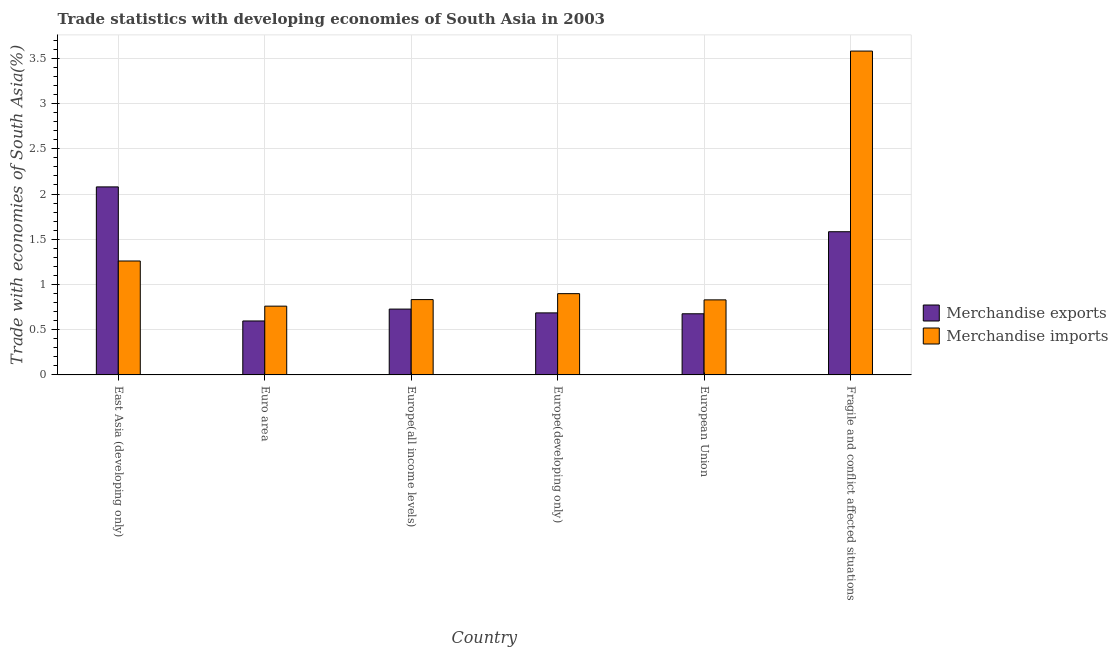How many different coloured bars are there?
Provide a succinct answer. 2. How many groups of bars are there?
Your answer should be very brief. 6. Are the number of bars per tick equal to the number of legend labels?
Provide a succinct answer. Yes. How many bars are there on the 3rd tick from the right?
Your answer should be compact. 2. What is the label of the 4th group of bars from the left?
Offer a very short reply. Europe(developing only). In how many cases, is the number of bars for a given country not equal to the number of legend labels?
Your answer should be very brief. 0. What is the merchandise imports in Europe(all income levels)?
Your answer should be compact. 0.83. Across all countries, what is the maximum merchandise exports?
Your answer should be compact. 2.08. Across all countries, what is the minimum merchandise exports?
Your answer should be very brief. 0.6. In which country was the merchandise imports maximum?
Your answer should be very brief. Fragile and conflict affected situations. In which country was the merchandise imports minimum?
Ensure brevity in your answer.  Euro area. What is the total merchandise exports in the graph?
Your response must be concise. 6.35. What is the difference between the merchandise exports in Europe(all income levels) and that in European Union?
Make the answer very short. 0.05. What is the difference between the merchandise imports in Euro area and the merchandise exports in European Union?
Offer a very short reply. 0.08. What is the average merchandise exports per country?
Your answer should be compact. 1.06. What is the difference between the merchandise exports and merchandise imports in East Asia (developing only)?
Ensure brevity in your answer.  0.82. In how many countries, is the merchandise exports greater than 3.5 %?
Offer a terse response. 0. What is the ratio of the merchandise imports in Europe(all income levels) to that in Fragile and conflict affected situations?
Your answer should be compact. 0.23. Is the merchandise exports in Euro area less than that in European Union?
Offer a very short reply. Yes. What is the difference between the highest and the second highest merchandise imports?
Your response must be concise. 2.32. What is the difference between the highest and the lowest merchandise imports?
Ensure brevity in your answer.  2.82. How many countries are there in the graph?
Keep it short and to the point. 6. Where does the legend appear in the graph?
Your response must be concise. Center right. What is the title of the graph?
Make the answer very short. Trade statistics with developing economies of South Asia in 2003. What is the label or title of the X-axis?
Give a very brief answer. Country. What is the label or title of the Y-axis?
Offer a terse response. Trade with economies of South Asia(%). What is the Trade with economies of South Asia(%) of Merchandise exports in East Asia (developing only)?
Keep it short and to the point. 2.08. What is the Trade with economies of South Asia(%) of Merchandise imports in East Asia (developing only)?
Keep it short and to the point. 1.26. What is the Trade with economies of South Asia(%) of Merchandise exports in Euro area?
Give a very brief answer. 0.6. What is the Trade with economies of South Asia(%) of Merchandise imports in Euro area?
Offer a terse response. 0.76. What is the Trade with economies of South Asia(%) in Merchandise exports in Europe(all income levels)?
Give a very brief answer. 0.73. What is the Trade with economies of South Asia(%) of Merchandise imports in Europe(all income levels)?
Keep it short and to the point. 0.83. What is the Trade with economies of South Asia(%) in Merchandise exports in Europe(developing only)?
Provide a succinct answer. 0.69. What is the Trade with economies of South Asia(%) in Merchandise imports in Europe(developing only)?
Your answer should be compact. 0.9. What is the Trade with economies of South Asia(%) of Merchandise exports in European Union?
Your answer should be compact. 0.68. What is the Trade with economies of South Asia(%) in Merchandise imports in European Union?
Offer a very short reply. 0.83. What is the Trade with economies of South Asia(%) of Merchandise exports in Fragile and conflict affected situations?
Offer a very short reply. 1.58. What is the Trade with economies of South Asia(%) of Merchandise imports in Fragile and conflict affected situations?
Keep it short and to the point. 3.58. Across all countries, what is the maximum Trade with economies of South Asia(%) of Merchandise exports?
Provide a succinct answer. 2.08. Across all countries, what is the maximum Trade with economies of South Asia(%) in Merchandise imports?
Your answer should be very brief. 3.58. Across all countries, what is the minimum Trade with economies of South Asia(%) of Merchandise exports?
Keep it short and to the point. 0.6. Across all countries, what is the minimum Trade with economies of South Asia(%) in Merchandise imports?
Ensure brevity in your answer.  0.76. What is the total Trade with economies of South Asia(%) in Merchandise exports in the graph?
Provide a short and direct response. 6.35. What is the total Trade with economies of South Asia(%) in Merchandise imports in the graph?
Provide a short and direct response. 8.16. What is the difference between the Trade with economies of South Asia(%) of Merchandise exports in East Asia (developing only) and that in Euro area?
Ensure brevity in your answer.  1.48. What is the difference between the Trade with economies of South Asia(%) of Merchandise imports in East Asia (developing only) and that in Euro area?
Your response must be concise. 0.5. What is the difference between the Trade with economies of South Asia(%) in Merchandise exports in East Asia (developing only) and that in Europe(all income levels)?
Offer a very short reply. 1.35. What is the difference between the Trade with economies of South Asia(%) in Merchandise imports in East Asia (developing only) and that in Europe(all income levels)?
Your answer should be compact. 0.43. What is the difference between the Trade with economies of South Asia(%) in Merchandise exports in East Asia (developing only) and that in Europe(developing only)?
Make the answer very short. 1.39. What is the difference between the Trade with economies of South Asia(%) in Merchandise imports in East Asia (developing only) and that in Europe(developing only)?
Provide a succinct answer. 0.36. What is the difference between the Trade with economies of South Asia(%) in Merchandise exports in East Asia (developing only) and that in European Union?
Your answer should be compact. 1.4. What is the difference between the Trade with economies of South Asia(%) of Merchandise imports in East Asia (developing only) and that in European Union?
Give a very brief answer. 0.43. What is the difference between the Trade with economies of South Asia(%) of Merchandise exports in East Asia (developing only) and that in Fragile and conflict affected situations?
Offer a very short reply. 0.5. What is the difference between the Trade with economies of South Asia(%) in Merchandise imports in East Asia (developing only) and that in Fragile and conflict affected situations?
Keep it short and to the point. -2.32. What is the difference between the Trade with economies of South Asia(%) of Merchandise exports in Euro area and that in Europe(all income levels)?
Offer a terse response. -0.13. What is the difference between the Trade with economies of South Asia(%) in Merchandise imports in Euro area and that in Europe(all income levels)?
Offer a terse response. -0.07. What is the difference between the Trade with economies of South Asia(%) in Merchandise exports in Euro area and that in Europe(developing only)?
Your answer should be very brief. -0.09. What is the difference between the Trade with economies of South Asia(%) of Merchandise imports in Euro area and that in Europe(developing only)?
Give a very brief answer. -0.14. What is the difference between the Trade with economies of South Asia(%) in Merchandise exports in Euro area and that in European Union?
Your answer should be very brief. -0.08. What is the difference between the Trade with economies of South Asia(%) in Merchandise imports in Euro area and that in European Union?
Your response must be concise. -0.07. What is the difference between the Trade with economies of South Asia(%) in Merchandise exports in Euro area and that in Fragile and conflict affected situations?
Give a very brief answer. -0.99. What is the difference between the Trade with economies of South Asia(%) of Merchandise imports in Euro area and that in Fragile and conflict affected situations?
Give a very brief answer. -2.82. What is the difference between the Trade with economies of South Asia(%) in Merchandise exports in Europe(all income levels) and that in Europe(developing only)?
Make the answer very short. 0.04. What is the difference between the Trade with economies of South Asia(%) of Merchandise imports in Europe(all income levels) and that in Europe(developing only)?
Your answer should be compact. -0.07. What is the difference between the Trade with economies of South Asia(%) in Merchandise exports in Europe(all income levels) and that in European Union?
Your response must be concise. 0.05. What is the difference between the Trade with economies of South Asia(%) of Merchandise imports in Europe(all income levels) and that in European Union?
Provide a short and direct response. 0. What is the difference between the Trade with economies of South Asia(%) in Merchandise exports in Europe(all income levels) and that in Fragile and conflict affected situations?
Your answer should be compact. -0.86. What is the difference between the Trade with economies of South Asia(%) in Merchandise imports in Europe(all income levels) and that in Fragile and conflict affected situations?
Provide a succinct answer. -2.75. What is the difference between the Trade with economies of South Asia(%) of Merchandise exports in Europe(developing only) and that in European Union?
Provide a short and direct response. 0.01. What is the difference between the Trade with economies of South Asia(%) in Merchandise imports in Europe(developing only) and that in European Union?
Provide a succinct answer. 0.07. What is the difference between the Trade with economies of South Asia(%) in Merchandise exports in Europe(developing only) and that in Fragile and conflict affected situations?
Keep it short and to the point. -0.9. What is the difference between the Trade with economies of South Asia(%) of Merchandise imports in Europe(developing only) and that in Fragile and conflict affected situations?
Ensure brevity in your answer.  -2.68. What is the difference between the Trade with economies of South Asia(%) in Merchandise exports in European Union and that in Fragile and conflict affected situations?
Make the answer very short. -0.91. What is the difference between the Trade with economies of South Asia(%) of Merchandise imports in European Union and that in Fragile and conflict affected situations?
Offer a terse response. -2.75. What is the difference between the Trade with economies of South Asia(%) in Merchandise exports in East Asia (developing only) and the Trade with economies of South Asia(%) in Merchandise imports in Euro area?
Ensure brevity in your answer.  1.32. What is the difference between the Trade with economies of South Asia(%) in Merchandise exports in East Asia (developing only) and the Trade with economies of South Asia(%) in Merchandise imports in Europe(all income levels)?
Your response must be concise. 1.25. What is the difference between the Trade with economies of South Asia(%) in Merchandise exports in East Asia (developing only) and the Trade with economies of South Asia(%) in Merchandise imports in Europe(developing only)?
Offer a very short reply. 1.18. What is the difference between the Trade with economies of South Asia(%) of Merchandise exports in East Asia (developing only) and the Trade with economies of South Asia(%) of Merchandise imports in European Union?
Offer a very short reply. 1.25. What is the difference between the Trade with economies of South Asia(%) in Merchandise exports in East Asia (developing only) and the Trade with economies of South Asia(%) in Merchandise imports in Fragile and conflict affected situations?
Keep it short and to the point. -1.5. What is the difference between the Trade with economies of South Asia(%) of Merchandise exports in Euro area and the Trade with economies of South Asia(%) of Merchandise imports in Europe(all income levels)?
Provide a short and direct response. -0.24. What is the difference between the Trade with economies of South Asia(%) of Merchandise exports in Euro area and the Trade with economies of South Asia(%) of Merchandise imports in Europe(developing only)?
Your answer should be compact. -0.3. What is the difference between the Trade with economies of South Asia(%) in Merchandise exports in Euro area and the Trade with economies of South Asia(%) in Merchandise imports in European Union?
Provide a succinct answer. -0.23. What is the difference between the Trade with economies of South Asia(%) in Merchandise exports in Euro area and the Trade with economies of South Asia(%) in Merchandise imports in Fragile and conflict affected situations?
Your answer should be compact. -2.98. What is the difference between the Trade with economies of South Asia(%) of Merchandise exports in Europe(all income levels) and the Trade with economies of South Asia(%) of Merchandise imports in Europe(developing only)?
Offer a very short reply. -0.17. What is the difference between the Trade with economies of South Asia(%) of Merchandise exports in Europe(all income levels) and the Trade with economies of South Asia(%) of Merchandise imports in European Union?
Your answer should be very brief. -0.1. What is the difference between the Trade with economies of South Asia(%) in Merchandise exports in Europe(all income levels) and the Trade with economies of South Asia(%) in Merchandise imports in Fragile and conflict affected situations?
Your response must be concise. -2.85. What is the difference between the Trade with economies of South Asia(%) of Merchandise exports in Europe(developing only) and the Trade with economies of South Asia(%) of Merchandise imports in European Union?
Your answer should be very brief. -0.14. What is the difference between the Trade with economies of South Asia(%) in Merchandise exports in Europe(developing only) and the Trade with economies of South Asia(%) in Merchandise imports in Fragile and conflict affected situations?
Ensure brevity in your answer.  -2.89. What is the difference between the Trade with economies of South Asia(%) in Merchandise exports in European Union and the Trade with economies of South Asia(%) in Merchandise imports in Fragile and conflict affected situations?
Your response must be concise. -2.9. What is the average Trade with economies of South Asia(%) in Merchandise exports per country?
Your answer should be compact. 1.06. What is the average Trade with economies of South Asia(%) in Merchandise imports per country?
Provide a short and direct response. 1.36. What is the difference between the Trade with economies of South Asia(%) of Merchandise exports and Trade with economies of South Asia(%) of Merchandise imports in East Asia (developing only)?
Provide a short and direct response. 0.82. What is the difference between the Trade with economies of South Asia(%) in Merchandise exports and Trade with economies of South Asia(%) in Merchandise imports in Euro area?
Provide a succinct answer. -0.16. What is the difference between the Trade with economies of South Asia(%) of Merchandise exports and Trade with economies of South Asia(%) of Merchandise imports in Europe(all income levels)?
Offer a very short reply. -0.1. What is the difference between the Trade with economies of South Asia(%) in Merchandise exports and Trade with economies of South Asia(%) in Merchandise imports in Europe(developing only)?
Keep it short and to the point. -0.21. What is the difference between the Trade with economies of South Asia(%) of Merchandise exports and Trade with economies of South Asia(%) of Merchandise imports in European Union?
Give a very brief answer. -0.15. What is the difference between the Trade with economies of South Asia(%) in Merchandise exports and Trade with economies of South Asia(%) in Merchandise imports in Fragile and conflict affected situations?
Provide a short and direct response. -2. What is the ratio of the Trade with economies of South Asia(%) of Merchandise exports in East Asia (developing only) to that in Euro area?
Your response must be concise. 3.49. What is the ratio of the Trade with economies of South Asia(%) in Merchandise imports in East Asia (developing only) to that in Euro area?
Provide a short and direct response. 1.66. What is the ratio of the Trade with economies of South Asia(%) of Merchandise exports in East Asia (developing only) to that in Europe(all income levels)?
Your answer should be very brief. 2.86. What is the ratio of the Trade with economies of South Asia(%) in Merchandise imports in East Asia (developing only) to that in Europe(all income levels)?
Ensure brevity in your answer.  1.51. What is the ratio of the Trade with economies of South Asia(%) in Merchandise exports in East Asia (developing only) to that in Europe(developing only)?
Your answer should be compact. 3.03. What is the ratio of the Trade with economies of South Asia(%) in Merchandise imports in East Asia (developing only) to that in Europe(developing only)?
Keep it short and to the point. 1.4. What is the ratio of the Trade with economies of South Asia(%) in Merchandise exports in East Asia (developing only) to that in European Union?
Your answer should be compact. 3.08. What is the ratio of the Trade with economies of South Asia(%) in Merchandise imports in East Asia (developing only) to that in European Union?
Your answer should be compact. 1.52. What is the ratio of the Trade with economies of South Asia(%) of Merchandise exports in East Asia (developing only) to that in Fragile and conflict affected situations?
Provide a succinct answer. 1.31. What is the ratio of the Trade with economies of South Asia(%) of Merchandise imports in East Asia (developing only) to that in Fragile and conflict affected situations?
Your answer should be very brief. 0.35. What is the ratio of the Trade with economies of South Asia(%) of Merchandise exports in Euro area to that in Europe(all income levels)?
Offer a very short reply. 0.82. What is the ratio of the Trade with economies of South Asia(%) in Merchandise imports in Euro area to that in Europe(all income levels)?
Ensure brevity in your answer.  0.91. What is the ratio of the Trade with economies of South Asia(%) in Merchandise exports in Euro area to that in Europe(developing only)?
Your response must be concise. 0.87. What is the ratio of the Trade with economies of South Asia(%) in Merchandise imports in Euro area to that in Europe(developing only)?
Your answer should be very brief. 0.85. What is the ratio of the Trade with economies of South Asia(%) of Merchandise exports in Euro area to that in European Union?
Offer a terse response. 0.88. What is the ratio of the Trade with economies of South Asia(%) in Merchandise imports in Euro area to that in European Union?
Keep it short and to the point. 0.92. What is the ratio of the Trade with economies of South Asia(%) of Merchandise exports in Euro area to that in Fragile and conflict affected situations?
Make the answer very short. 0.38. What is the ratio of the Trade with economies of South Asia(%) of Merchandise imports in Euro area to that in Fragile and conflict affected situations?
Keep it short and to the point. 0.21. What is the ratio of the Trade with economies of South Asia(%) of Merchandise exports in Europe(all income levels) to that in Europe(developing only)?
Offer a terse response. 1.06. What is the ratio of the Trade with economies of South Asia(%) of Merchandise imports in Europe(all income levels) to that in Europe(developing only)?
Give a very brief answer. 0.93. What is the ratio of the Trade with economies of South Asia(%) of Merchandise exports in Europe(all income levels) to that in European Union?
Offer a very short reply. 1.08. What is the ratio of the Trade with economies of South Asia(%) in Merchandise exports in Europe(all income levels) to that in Fragile and conflict affected situations?
Ensure brevity in your answer.  0.46. What is the ratio of the Trade with economies of South Asia(%) in Merchandise imports in Europe(all income levels) to that in Fragile and conflict affected situations?
Give a very brief answer. 0.23. What is the ratio of the Trade with economies of South Asia(%) of Merchandise exports in Europe(developing only) to that in European Union?
Give a very brief answer. 1.01. What is the ratio of the Trade with economies of South Asia(%) in Merchandise imports in Europe(developing only) to that in European Union?
Your answer should be very brief. 1.08. What is the ratio of the Trade with economies of South Asia(%) of Merchandise exports in Europe(developing only) to that in Fragile and conflict affected situations?
Offer a very short reply. 0.43. What is the ratio of the Trade with economies of South Asia(%) in Merchandise imports in Europe(developing only) to that in Fragile and conflict affected situations?
Provide a short and direct response. 0.25. What is the ratio of the Trade with economies of South Asia(%) of Merchandise exports in European Union to that in Fragile and conflict affected situations?
Give a very brief answer. 0.43. What is the ratio of the Trade with economies of South Asia(%) in Merchandise imports in European Union to that in Fragile and conflict affected situations?
Keep it short and to the point. 0.23. What is the difference between the highest and the second highest Trade with economies of South Asia(%) in Merchandise exports?
Provide a short and direct response. 0.5. What is the difference between the highest and the second highest Trade with economies of South Asia(%) in Merchandise imports?
Your answer should be very brief. 2.32. What is the difference between the highest and the lowest Trade with economies of South Asia(%) in Merchandise exports?
Your answer should be compact. 1.48. What is the difference between the highest and the lowest Trade with economies of South Asia(%) of Merchandise imports?
Give a very brief answer. 2.82. 